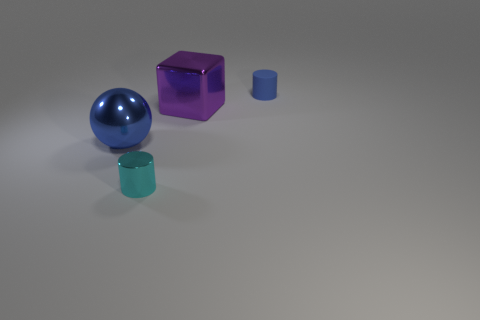Add 4 small purple blocks. How many objects exist? 8 Subtract all balls. How many objects are left? 3 Subtract 0 green balls. How many objects are left? 4 Subtract all tiny things. Subtract all big gray shiny cubes. How many objects are left? 2 Add 3 cyan cylinders. How many cyan cylinders are left? 4 Add 4 cyan metallic cylinders. How many cyan metallic cylinders exist? 5 